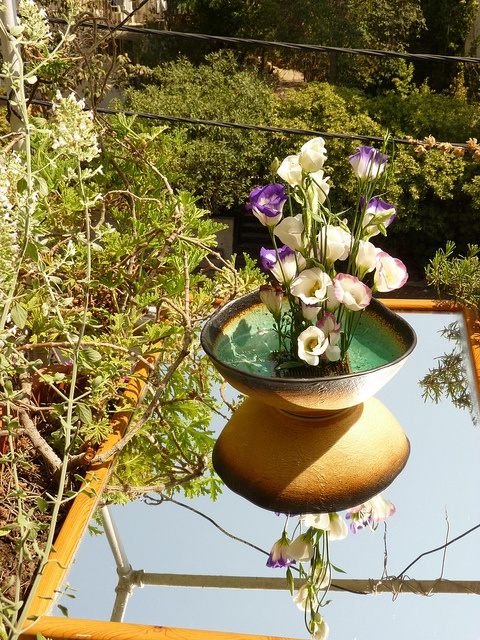Describe the objects in this image and their specific colors. I can see potted plant in khaki, black, maroon, olive, and beige tones, vase in khaki, maroon, and beige tones, and vase in khaki, black, olive, maroon, and darkgreen tones in this image. 